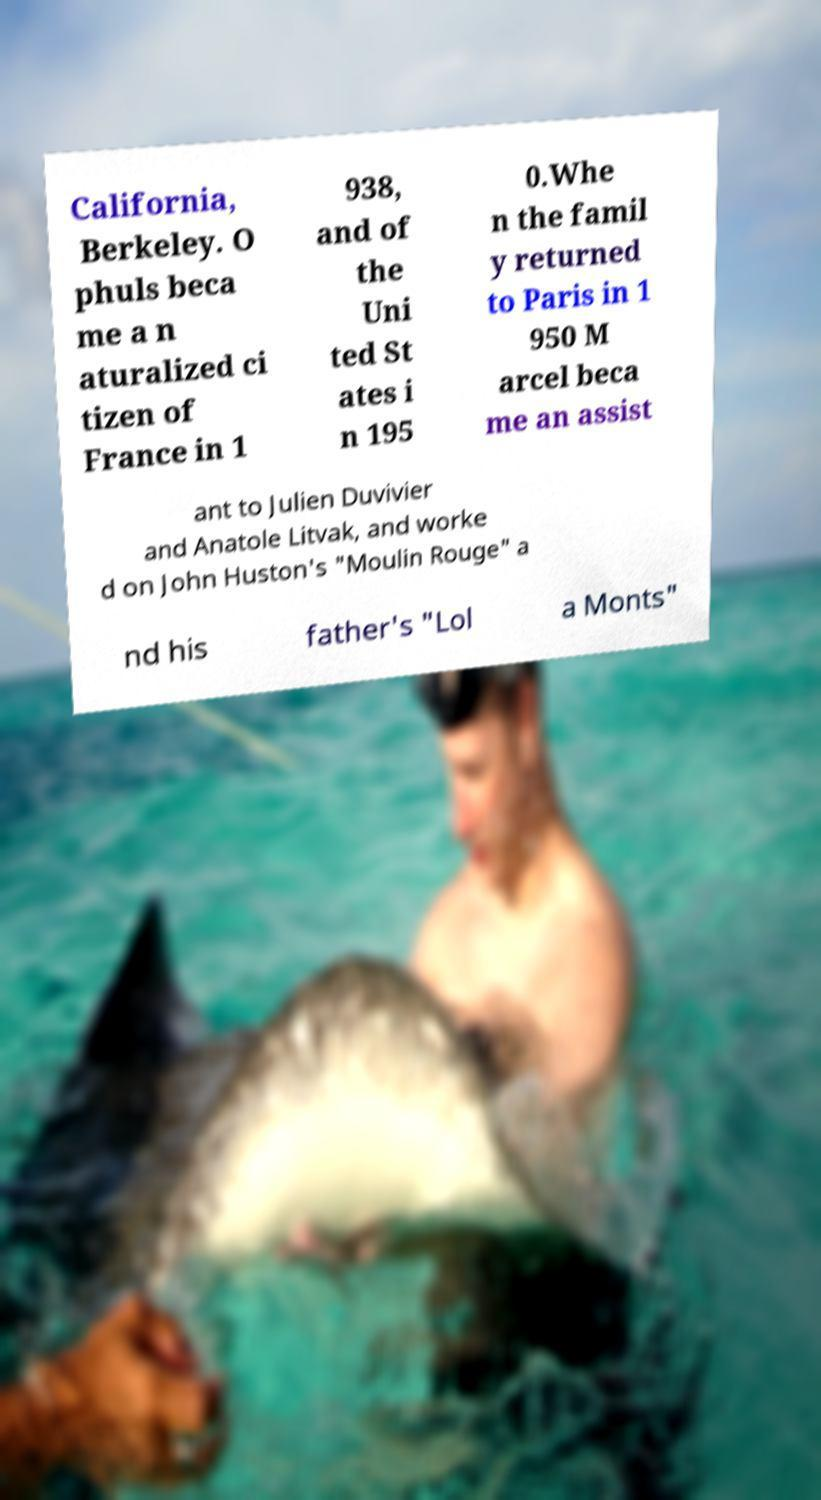Can you read and provide the text displayed in the image?This photo seems to have some interesting text. Can you extract and type it out for me? California, Berkeley. O phuls beca me a n aturalized ci tizen of France in 1 938, and of the Uni ted St ates i n 195 0.Whe n the famil y returned to Paris in 1 950 M arcel beca me an assist ant to Julien Duvivier and Anatole Litvak, and worke d on John Huston's "Moulin Rouge" a nd his father's "Lol a Monts" 